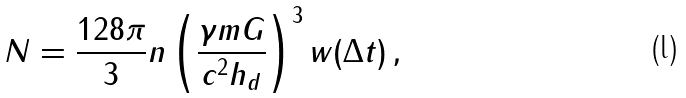Convert formula to latex. <formula><loc_0><loc_0><loc_500><loc_500>N = \frac { 1 2 8 \pi } { 3 } n \left ( { \frac { \gamma m G } { { c ^ { 2 } h _ { d } } } } \right ) ^ { 3 } w ( \Delta t ) \, ,</formula> 